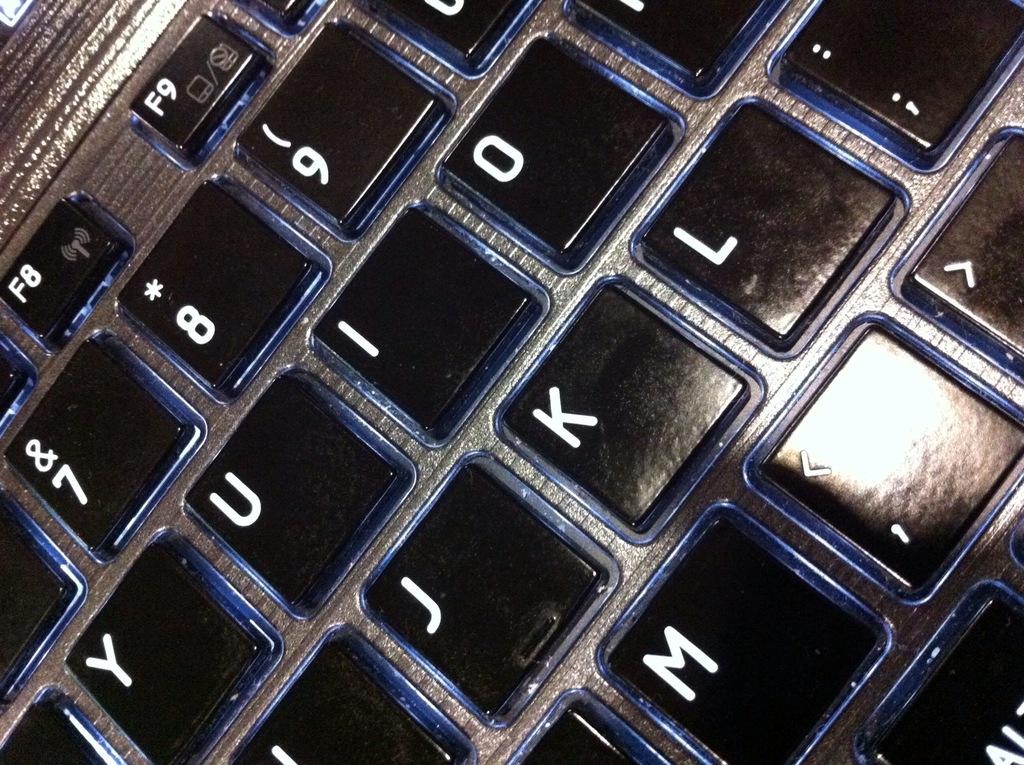What f-keys are shown?
Offer a terse response. F8 f9. 